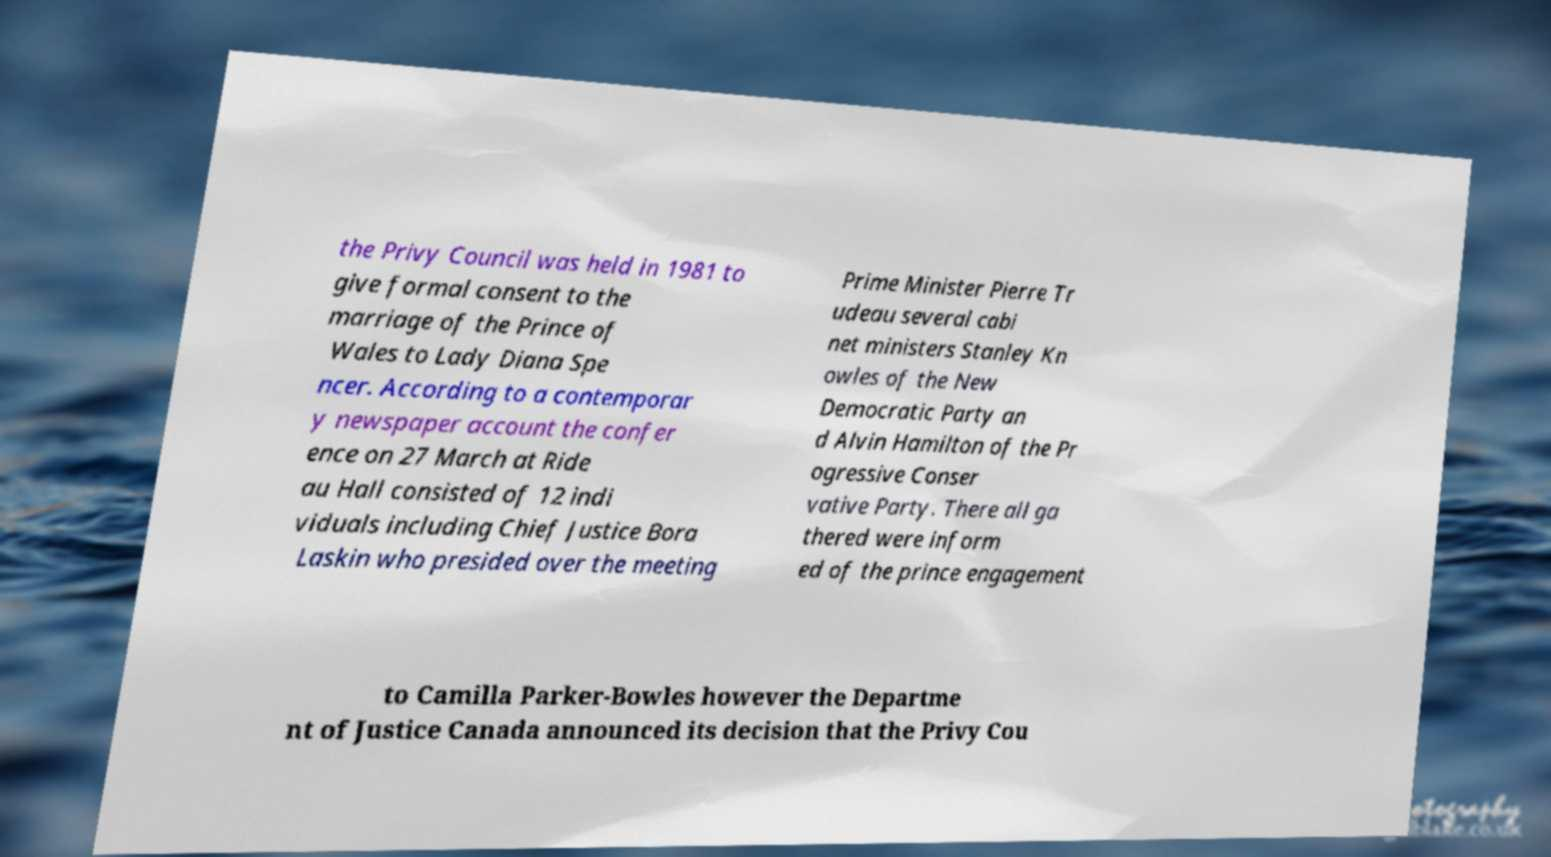Please read and relay the text visible in this image. What does it say? the Privy Council was held in 1981 to give formal consent to the marriage of the Prince of Wales to Lady Diana Spe ncer. According to a contemporar y newspaper account the confer ence on 27 March at Ride au Hall consisted of 12 indi viduals including Chief Justice Bora Laskin who presided over the meeting Prime Minister Pierre Tr udeau several cabi net ministers Stanley Kn owles of the New Democratic Party an d Alvin Hamilton of the Pr ogressive Conser vative Party. There all ga thered were inform ed of the prince engagement to Camilla Parker-Bowles however the Departme nt of Justice Canada announced its decision that the Privy Cou 